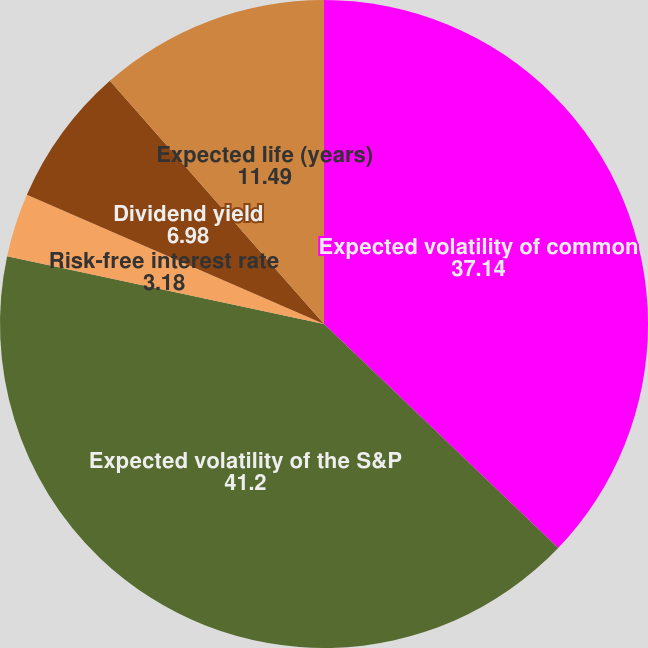<chart> <loc_0><loc_0><loc_500><loc_500><pie_chart><fcel>Expected volatility of common<fcel>Expected volatility of the S&P<fcel>Risk-free interest rate<fcel>Dividend yield<fcel>Expected life (years)<nl><fcel>37.14%<fcel>41.2%<fcel>3.18%<fcel>6.98%<fcel>11.49%<nl></chart> 